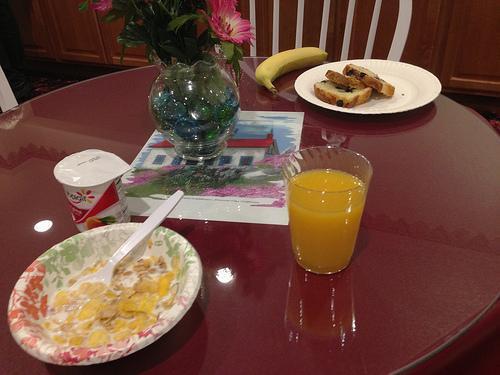How many plates?
Give a very brief answer. 2. 